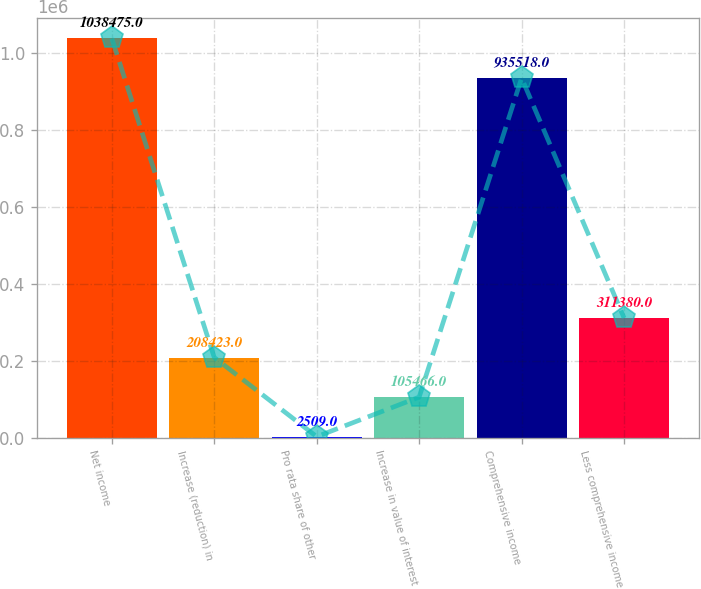<chart> <loc_0><loc_0><loc_500><loc_500><bar_chart><fcel>Net income<fcel>Increase (reduction) in<fcel>Pro rata share of other<fcel>Increase in value of interest<fcel>Comprehensive income<fcel>Less comprehensive income<nl><fcel>1.03848e+06<fcel>208423<fcel>2509<fcel>105466<fcel>935518<fcel>311380<nl></chart> 